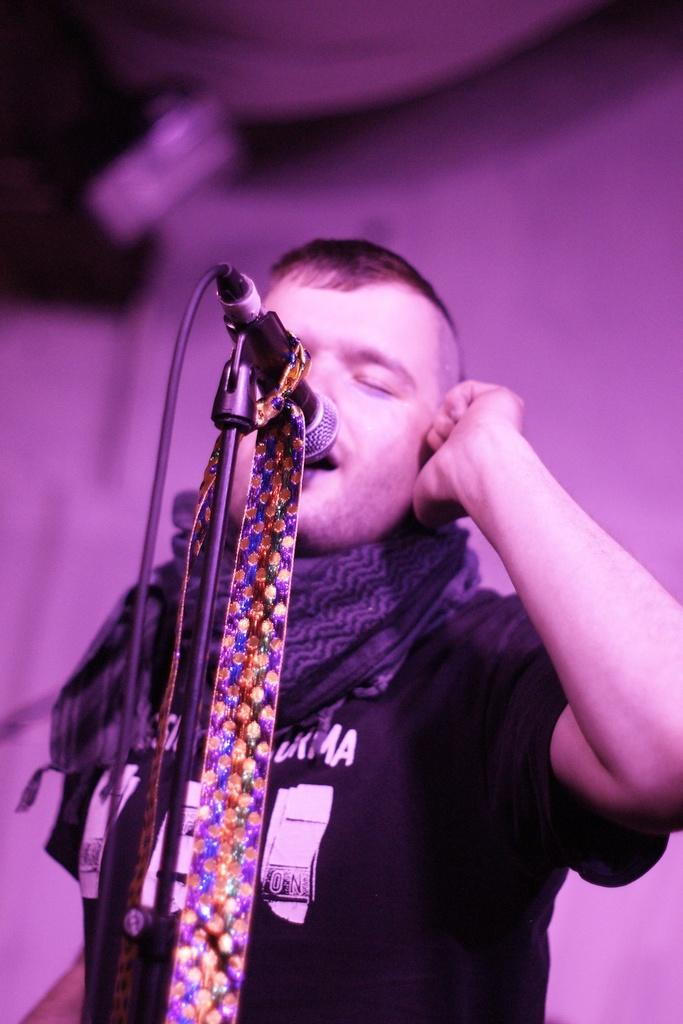What is the main subject of the image? There is a person standing in the image. What is the person wearing in the image? The person is wearing a shirt and a scarf. What object can be seen near the person in the image? There is a microphone in the image. What is visible in the background of the image? There is a wall in the background of the image. How many tomatoes are being smashed by the person in the image? There are no tomatoes or smashing activity present in the image. What type of clam is visible on the person's shirt in the image? There is no clam visible on the person's shirt in the image. 